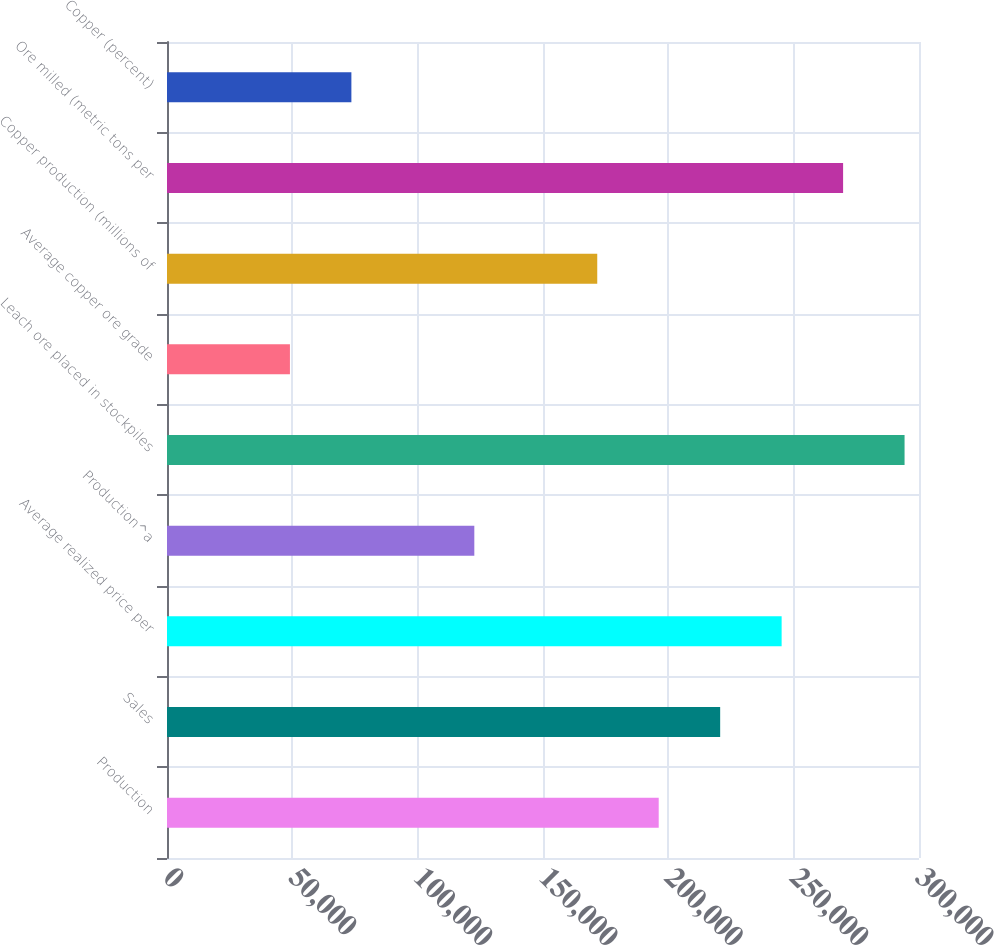Convert chart to OTSL. <chart><loc_0><loc_0><loc_500><loc_500><bar_chart><fcel>Production<fcel>Sales<fcel>Average realized price per<fcel>Production^a<fcel>Leach ore placed in stockpiles<fcel>Average copper ore grade<fcel>Copper production (millions of<fcel>Ore milled (metric tons per<fcel>Copper (percent)<nl><fcel>196160<fcel>220680<fcel>245200<fcel>122600<fcel>294240<fcel>49040<fcel>171640<fcel>269720<fcel>73560<nl></chart> 